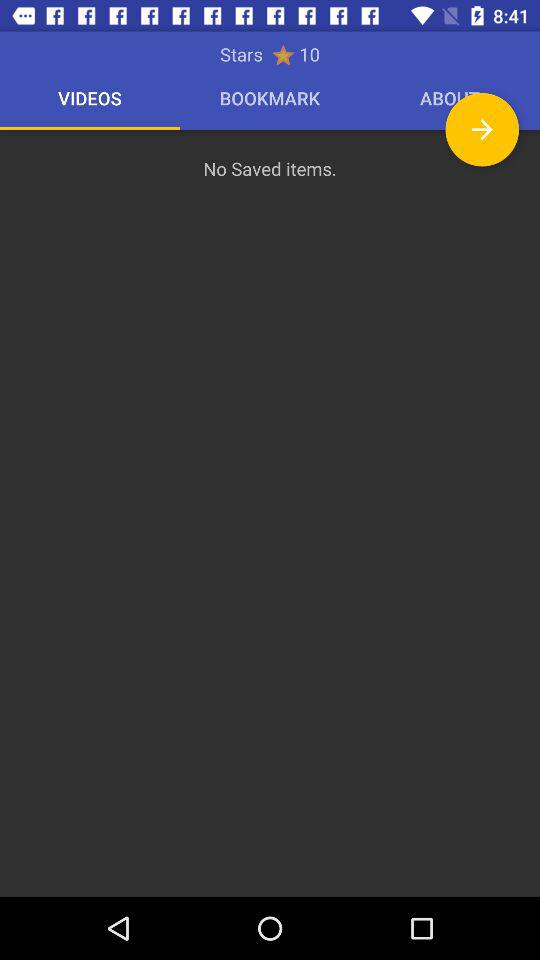How many items are saved? There are no items saved. 